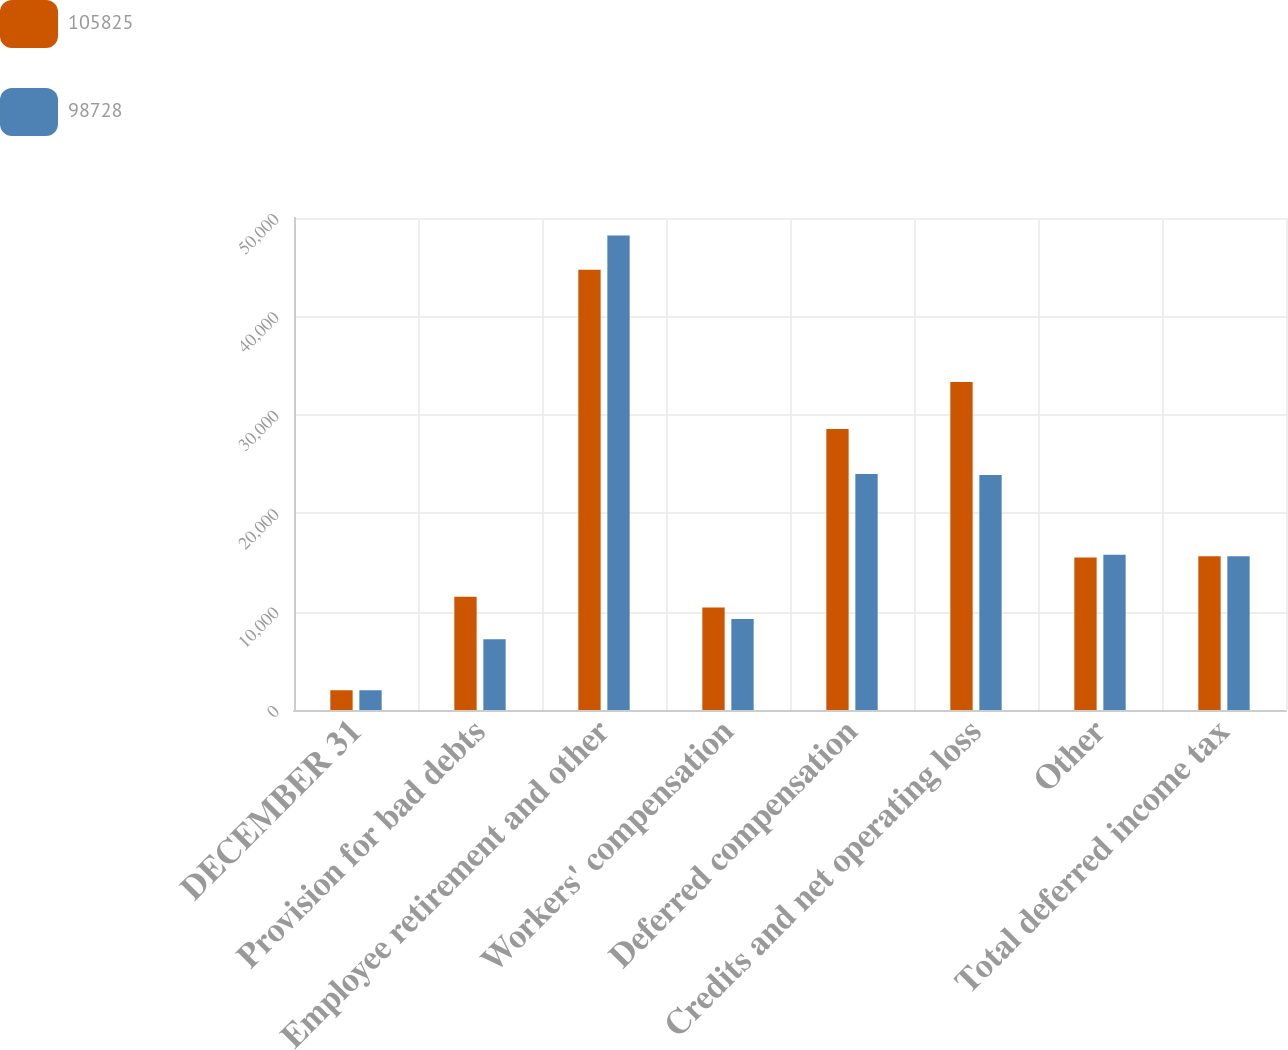Convert chart to OTSL. <chart><loc_0><loc_0><loc_500><loc_500><stacked_bar_chart><ecel><fcel>DECEMBER 31<fcel>Provision for bad debts<fcel>Employee retirement and other<fcel>Workers' compensation<fcel>Deferred compensation<fcel>Credits and net operating loss<fcel>Other<fcel>Total deferred income tax<nl><fcel>105825<fcel>2008<fcel>11521<fcel>44733<fcel>10404<fcel>28567<fcel>33330<fcel>15491<fcel>15632<nl><fcel>98728<fcel>2007<fcel>7191<fcel>48219<fcel>9245<fcel>23979<fcel>23892<fcel>15773<fcel>15632<nl></chart> 